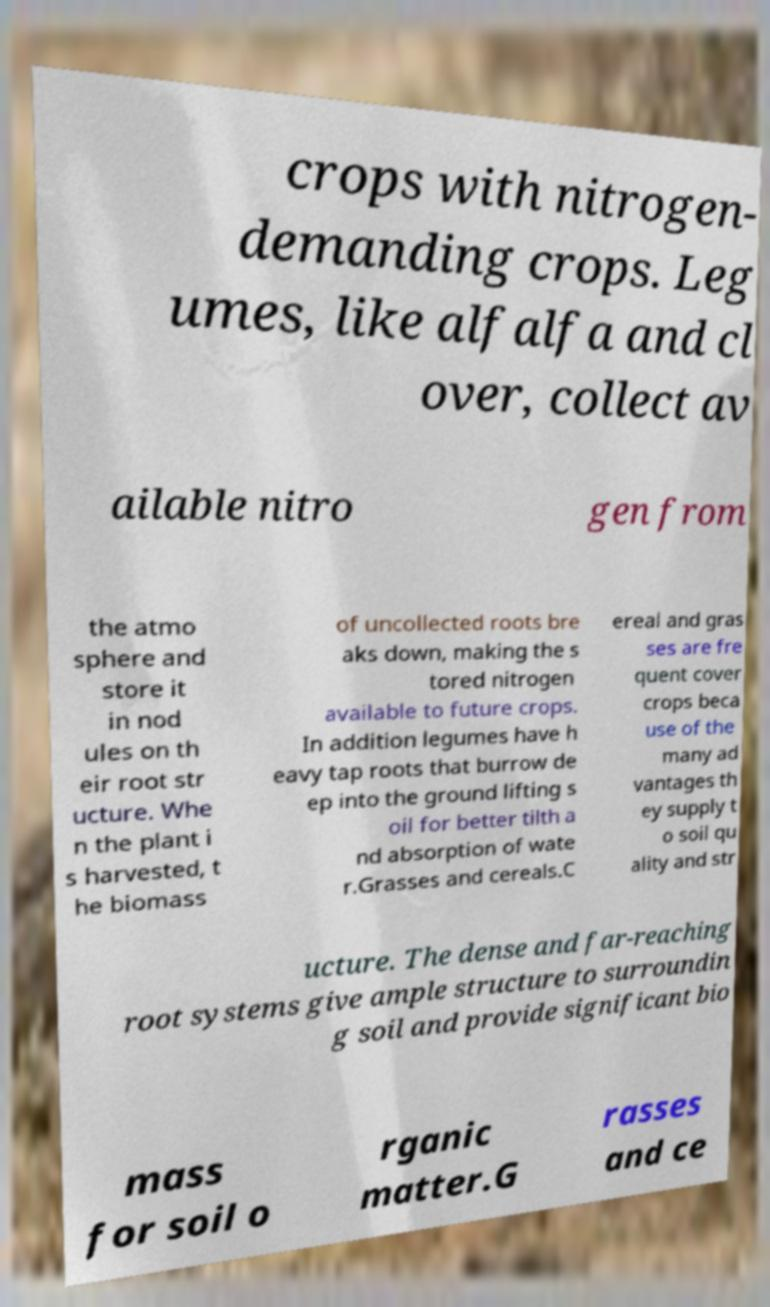What messages or text are displayed in this image? I need them in a readable, typed format. crops with nitrogen- demanding crops. Leg umes, like alfalfa and cl over, collect av ailable nitro gen from the atmo sphere and store it in nod ules on th eir root str ucture. Whe n the plant i s harvested, t he biomass of uncollected roots bre aks down, making the s tored nitrogen available to future crops. In addition legumes have h eavy tap roots that burrow de ep into the ground lifting s oil for better tilth a nd absorption of wate r.Grasses and cereals.C ereal and gras ses are fre quent cover crops beca use of the many ad vantages th ey supply t o soil qu ality and str ucture. The dense and far-reaching root systems give ample structure to surroundin g soil and provide significant bio mass for soil o rganic matter.G rasses and ce 